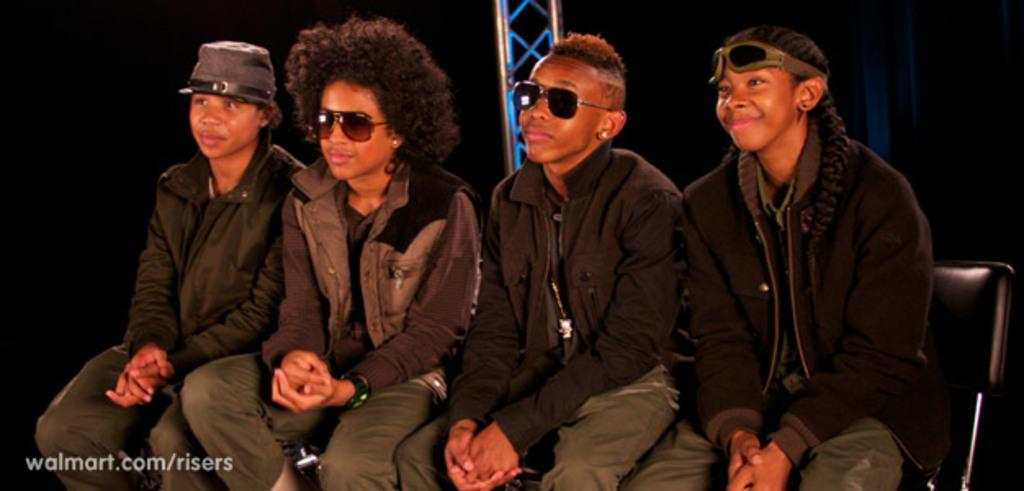How many people are sitting in the image? There are four people sitting on chairs in the image. Can you describe the seating arrangement in the image? The four people are sitting on chairs. What can be seen in the background of the image? There is a pole in the background of the image. What type of tub is visible in the image? There is no tub present in the image. Can you describe the basketball game happening in the image? There is no basketball game present in the image. 